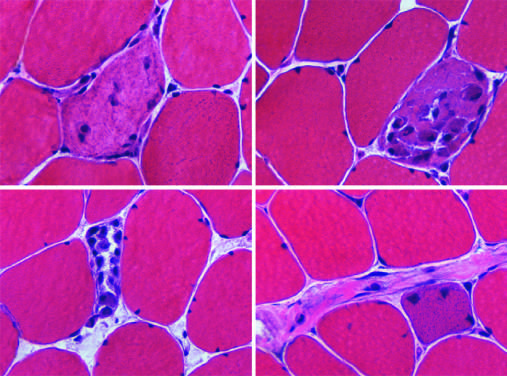re the least common but molecularly most distinctive type of breast cancer infiltrated by variable numbers of inflammatory cells?
Answer the question using a single word or phrase. No 